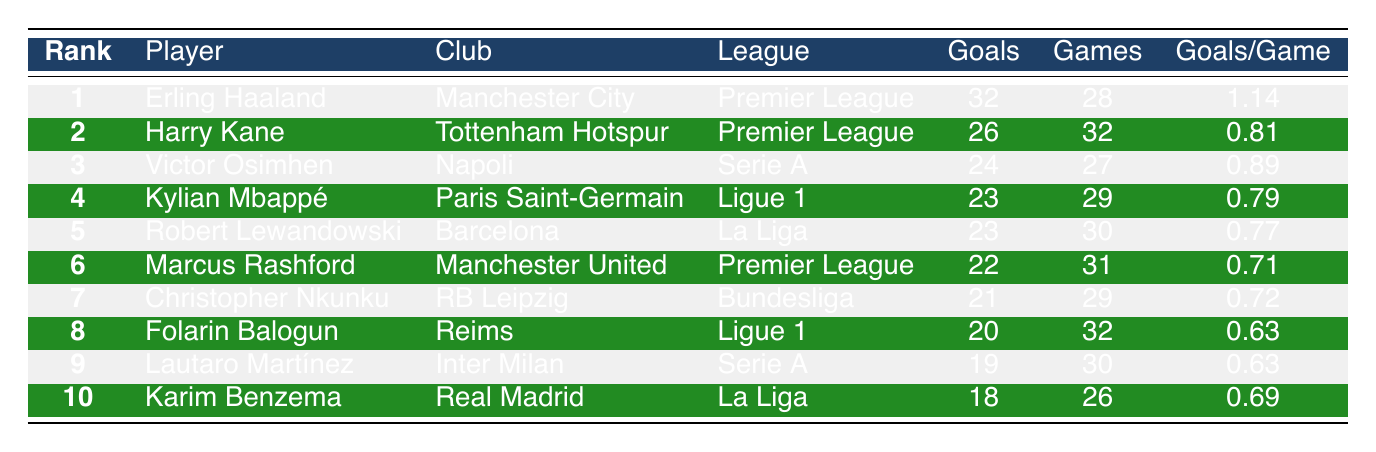What is the total number of goals scored by the top 3 players? The top 3 players are Erling Haaland with 32 goals, Harry Kane with 26 goals, and Victor Osimhen with 24 goals. To find the total, we add these values: 32 + 26 + 24 = 82.
Answer: 82 Which league has the player with the highest goals per game? Erling Haaland from the Premier League has the highest goals per game, with a rate of 1.14. No other player exceeds this value, making the Premier League the league with the player who has the highest goals per game.
Answer: Premier League Is Harry Kane in the top 5 goal scorers? Yes, Harry Kane is ranked 2nd with 26 goals, which places him in the top 5 of the goal scorers table.
Answer: Yes What is the difference in goals between the player ranked 1st and the player ranked 10th? The player in 1st place, Erling Haaland, has 32 goals, while the player in 10th place, Karim Benzema, has 18 goals. The difference is calculated as 32 - 18 = 14.
Answer: 14 How many players have scored 20 or more goals this season? The players with 20 or more goals are Erling Haaland (32), Harry Kane (26), Victor Osimhen (24), Kylian Mbappé (23), Robert Lewandowski (23), and Marcus Rashford (22). There are a total of 6 players with 20 or more goals.
Answer: 6 What is the average number of goals scored by the top 10 players? To find the average, first add the goals of all top 10 players: 32 + 26 + 24 + 23 + 23 + 22 + 21 + 20 + 19 + 18 =  218. Since there are 10 players, divide by 10: 218 / 10 = 21.8.
Answer: 21.8 Has Kylian Mbappé scored more goals than Robert Lewandowski? No, both Kylian Mbappé and Robert Lewandowski have scored 23 goals each, so Kylian Mbappé has not scored more than Robert Lewandowski.
Answer: No Which player has played the fewest games to achieve their goals? Karim Benzema has played 26 games and scored 18 goals, which is fewer games than any other player in the top 10.
Answer: Karim Benzema 